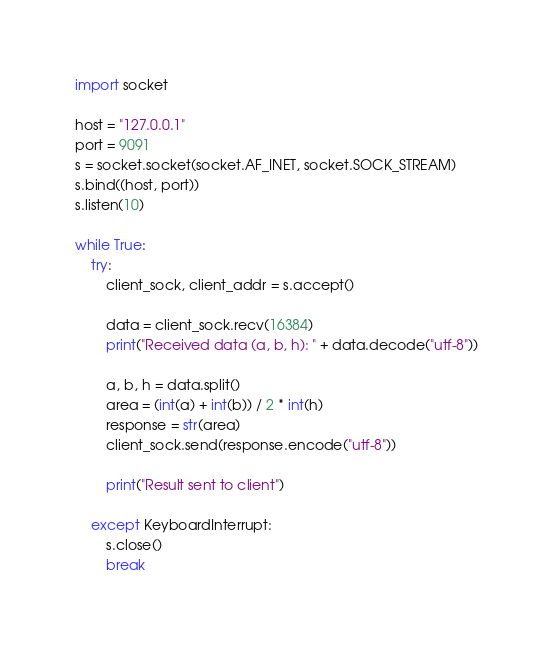Convert code to text. <code><loc_0><loc_0><loc_500><loc_500><_Python_>import socket

host = "127.0.0.1"
port = 9091
s = socket.socket(socket.AF_INET, socket.SOCK_STREAM)
s.bind((host, port))
s.listen(10)

while True:
	try:
		client_sock, client_addr = s.accept()

		data = client_sock.recv(16384)
		print("Received data (a, b, h): " + data.decode("utf-8"))

		a, b, h = data.split()
		area = (int(a) + int(b)) / 2 * int(h)
		response = str(area)
		client_sock.send(response.encode("utf-8"))

		print("Result sent to client")

	except KeyboardInterrupt:
		s.close()
		break

</code> 